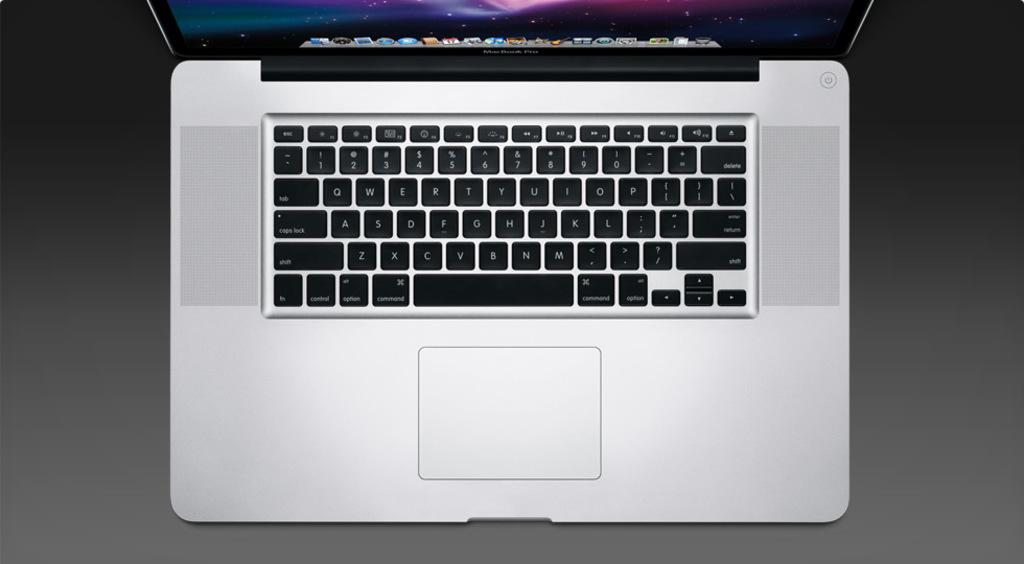<image>
Relay a brief, clear account of the picture shown. A MacBook keyboard has the Z key right next to the X key. 